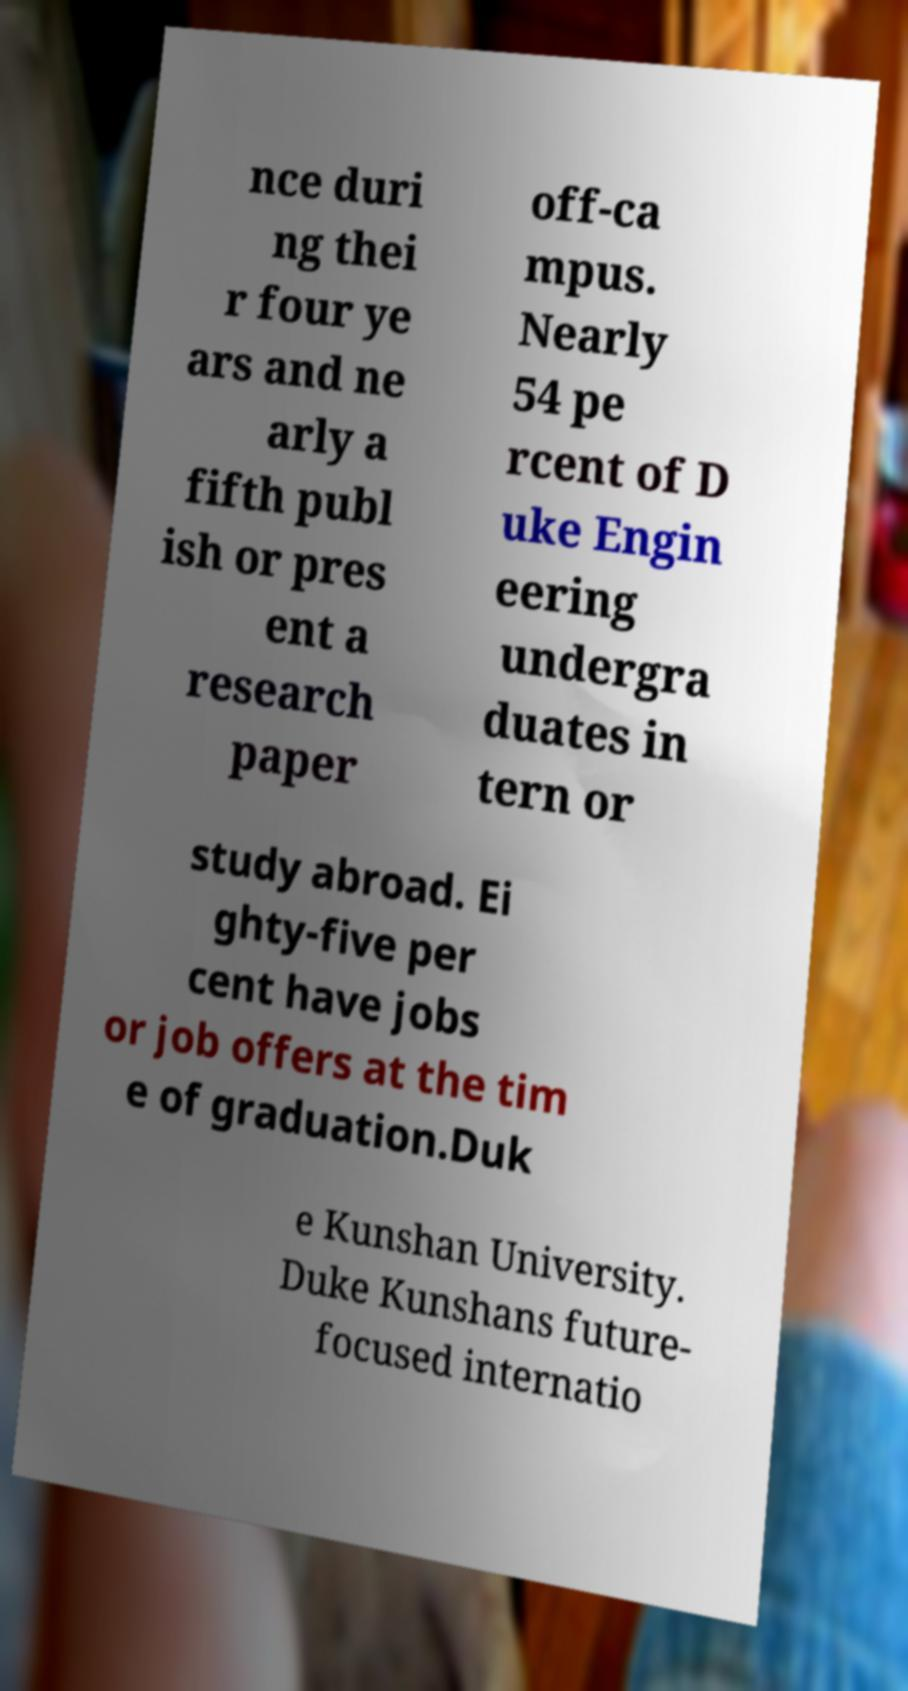Can you read and provide the text displayed in the image?This photo seems to have some interesting text. Can you extract and type it out for me? nce duri ng thei r four ye ars and ne arly a fifth publ ish or pres ent a research paper off-ca mpus. Nearly 54 pe rcent of D uke Engin eering undergra duates in tern or study abroad. Ei ghty-five per cent have jobs or job offers at the tim e of graduation.Duk e Kunshan University. Duke Kunshans future- focused internatio 